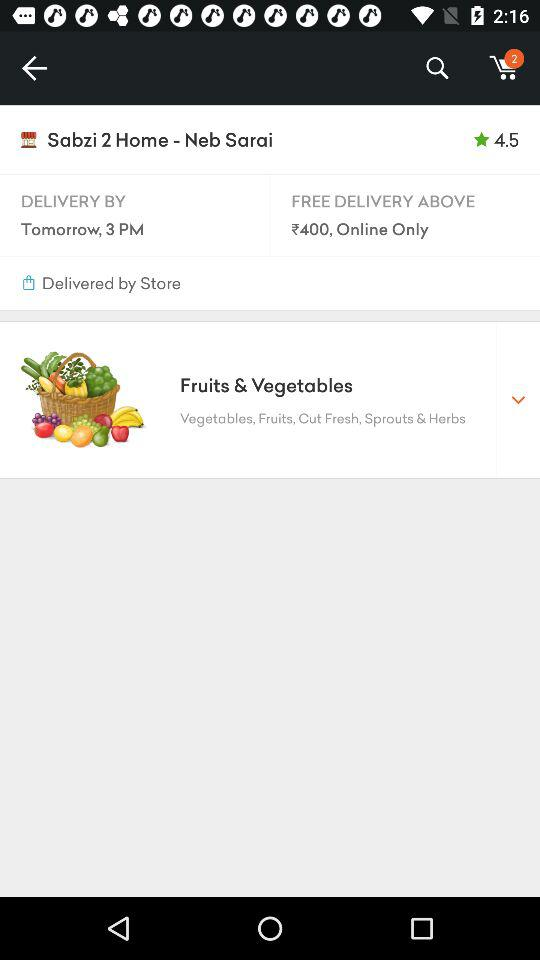At what time will the order be delivered? The order will be delivered by 3 PM tomorrow. 